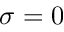Convert formula to latex. <formula><loc_0><loc_0><loc_500><loc_500>\sigma = 0</formula> 